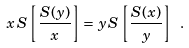Convert formula to latex. <formula><loc_0><loc_0><loc_500><loc_500>x \, S \left [ \frac { S ( y ) } { x } \right ] = y \, S \left [ \frac { S ( x ) } { y } \right ] \ .</formula> 